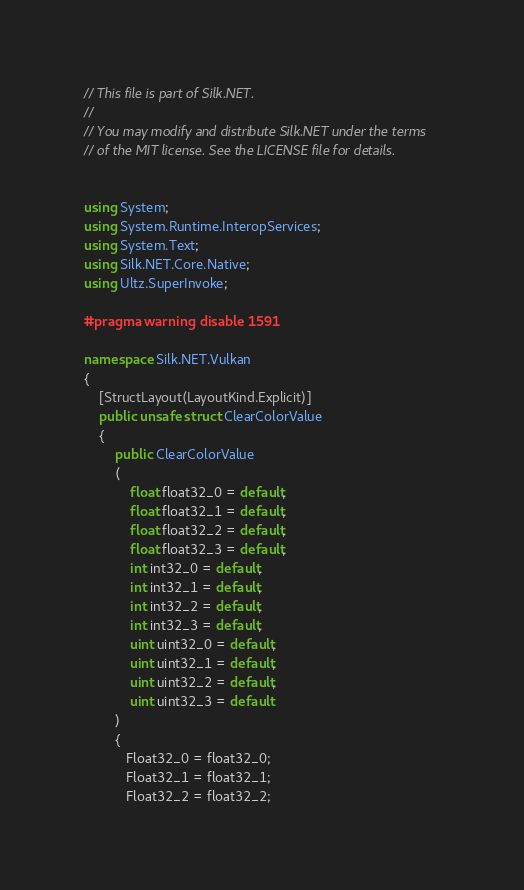Convert code to text. <code><loc_0><loc_0><loc_500><loc_500><_C#_>// This file is part of Silk.NET.
// 
// You may modify and distribute Silk.NET under the terms
// of the MIT license. See the LICENSE file for details.


using System;
using System.Runtime.InteropServices;
using System.Text;
using Silk.NET.Core.Native;
using Ultz.SuperInvoke;

#pragma warning disable 1591

namespace Silk.NET.Vulkan
{
    [StructLayout(LayoutKind.Explicit)]
    public unsafe struct ClearColorValue
    {
        public ClearColorValue
        (
            float float32_0 = default,
            float float32_1 = default,
            float float32_2 = default,
            float float32_3 = default,
            int int32_0 = default,
            int int32_1 = default,
            int int32_2 = default,
            int int32_3 = default,
            uint uint32_0 = default,
            uint uint32_1 = default,
            uint uint32_2 = default,
            uint uint32_3 = default
        )
        {
           Float32_0 = float32_0;
           Float32_1 = float32_1;
           Float32_2 = float32_2;</code> 